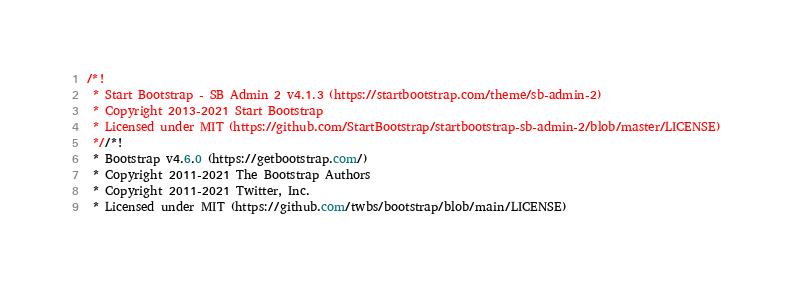Convert code to text. <code><loc_0><loc_0><loc_500><loc_500><_CSS_>/*!
 * Start Bootstrap - SB Admin 2 v4.1.3 (https://startbootstrap.com/theme/sb-admin-2)
 * Copyright 2013-2021 Start Bootstrap
 * Licensed under MIT (https://github.com/StartBootstrap/startbootstrap-sb-admin-2/blob/master/LICENSE)
 *//*!
 * Bootstrap v4.6.0 (https://getbootstrap.com/)
 * Copyright 2011-2021 The Bootstrap Authors
 * Copyright 2011-2021 Twitter, Inc.
 * Licensed under MIT (https://github.com/twbs/bootstrap/blob/main/LICENSE)</code> 